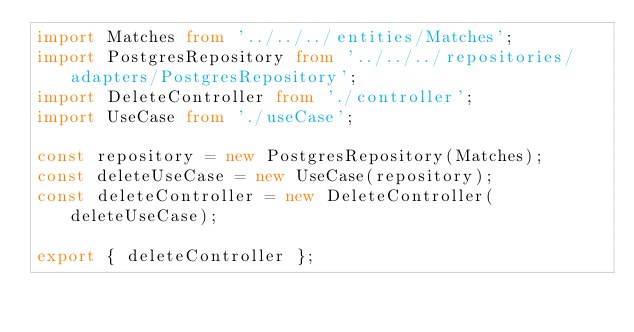Convert code to text. <code><loc_0><loc_0><loc_500><loc_500><_TypeScript_>import Matches from '../../../entities/Matches';
import PostgresRepository from '../../../repositories/adapters/PostgresRepository';
import DeleteController from './controller';
import UseCase from './useCase';

const repository = new PostgresRepository(Matches);
const deleteUseCase = new UseCase(repository);
const deleteController = new DeleteController(deleteUseCase);

export { deleteController };
</code> 